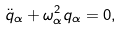Convert formula to latex. <formula><loc_0><loc_0><loc_500><loc_500>\ddot { q } _ { \alpha } + \omega _ { \alpha } ^ { 2 } q _ { \alpha } = 0 ,</formula> 